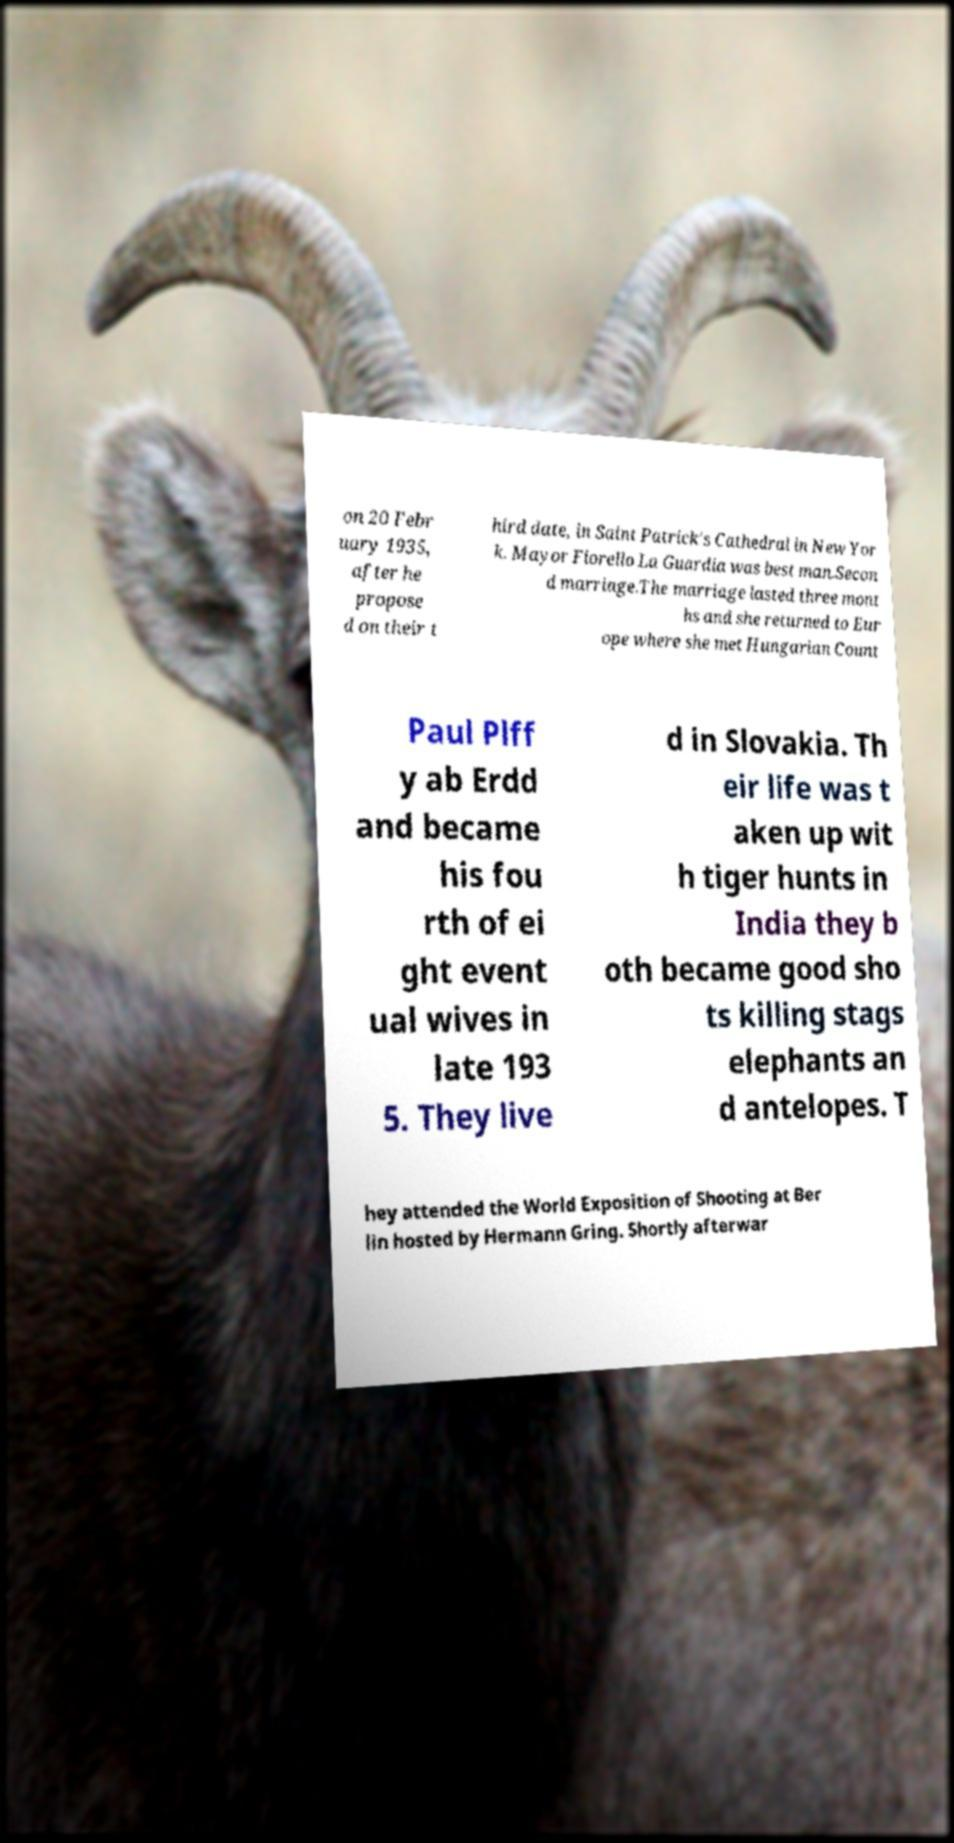What messages or text are displayed in this image? I need them in a readable, typed format. on 20 Febr uary 1935, after he propose d on their t hird date, in Saint Patrick's Cathedral in New Yor k. Mayor Fiorello La Guardia was best man.Secon d marriage.The marriage lasted three mont hs and she returned to Eur ope where she met Hungarian Count Paul Plff y ab Erdd and became his fou rth of ei ght event ual wives in late 193 5. They live d in Slovakia. Th eir life was t aken up wit h tiger hunts in India they b oth became good sho ts killing stags elephants an d antelopes. T hey attended the World Exposition of Shooting at Ber lin hosted by Hermann Gring. Shortly afterwar 